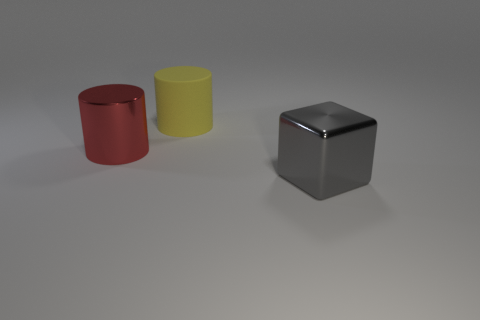Are the objects arranged in any particular pattern? The objects are spaced evenly from one another in a straight line across the surface, suggesting a deliberate and orderly arrangement.  Is there anything about the colors of the objects that stands out to you? The colors of the cylinders—red and yellow—create a contrast with the neutral grey of the cube, which draws the eye to the variance in both shape and hue among the items. 